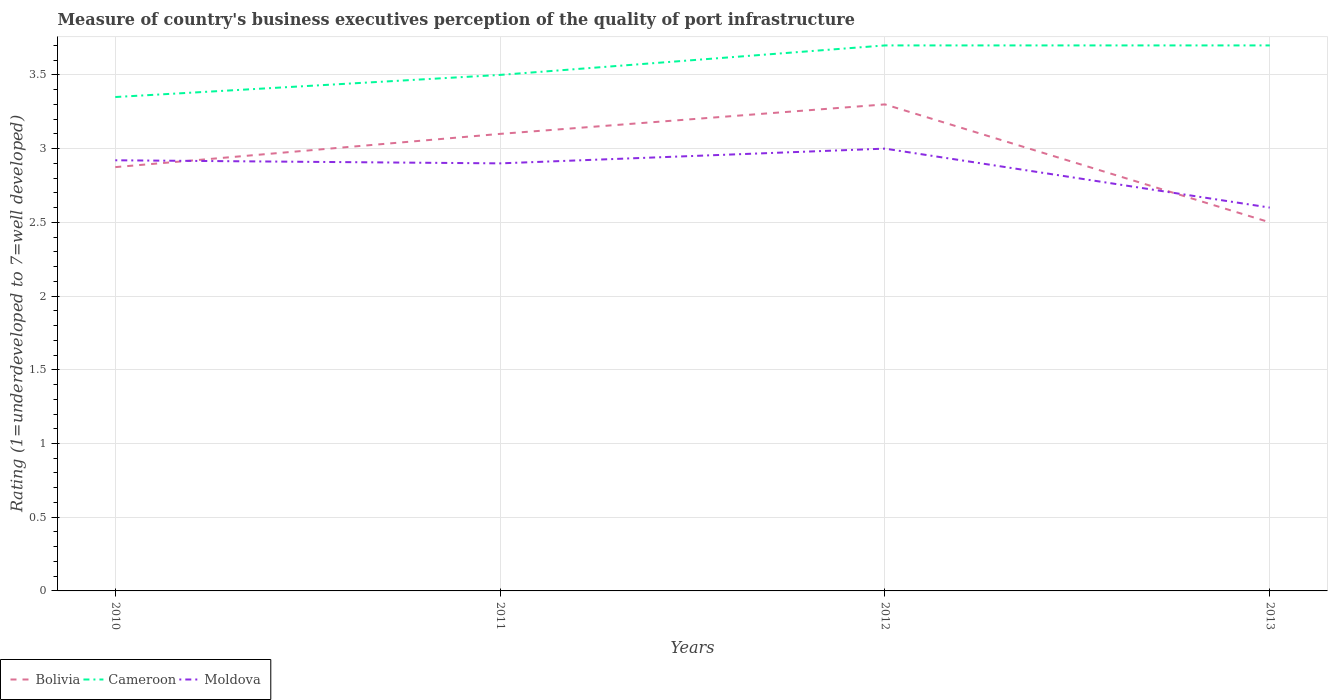What is the total ratings of the quality of port infrastructure in Cameroon in the graph?
Make the answer very short. -0.2. What is the difference between the highest and the second highest ratings of the quality of port infrastructure in Bolivia?
Make the answer very short. 0.8. Is the ratings of the quality of port infrastructure in Cameroon strictly greater than the ratings of the quality of port infrastructure in Moldova over the years?
Your answer should be compact. No. How many lines are there?
Provide a succinct answer. 3. What is the difference between two consecutive major ticks on the Y-axis?
Offer a terse response. 0.5. Are the values on the major ticks of Y-axis written in scientific E-notation?
Your answer should be very brief. No. Does the graph contain any zero values?
Give a very brief answer. No. How many legend labels are there?
Your answer should be compact. 3. What is the title of the graph?
Offer a terse response. Measure of country's business executives perception of the quality of port infrastructure. What is the label or title of the X-axis?
Ensure brevity in your answer.  Years. What is the label or title of the Y-axis?
Make the answer very short. Rating (1=underdeveloped to 7=well developed). What is the Rating (1=underdeveloped to 7=well developed) in Bolivia in 2010?
Give a very brief answer. 2.87. What is the Rating (1=underdeveloped to 7=well developed) of Cameroon in 2010?
Offer a very short reply. 3.35. What is the Rating (1=underdeveloped to 7=well developed) of Moldova in 2010?
Your response must be concise. 2.92. What is the Rating (1=underdeveloped to 7=well developed) in Moldova in 2011?
Give a very brief answer. 2.9. What is the Rating (1=underdeveloped to 7=well developed) in Bolivia in 2012?
Your response must be concise. 3.3. What is the Rating (1=underdeveloped to 7=well developed) in Cameroon in 2012?
Make the answer very short. 3.7. What is the Rating (1=underdeveloped to 7=well developed) in Cameroon in 2013?
Keep it short and to the point. 3.7. Across all years, what is the maximum Rating (1=underdeveloped to 7=well developed) of Moldova?
Provide a short and direct response. 3. Across all years, what is the minimum Rating (1=underdeveloped to 7=well developed) in Bolivia?
Keep it short and to the point. 2.5. Across all years, what is the minimum Rating (1=underdeveloped to 7=well developed) of Cameroon?
Offer a terse response. 3.35. What is the total Rating (1=underdeveloped to 7=well developed) in Bolivia in the graph?
Offer a terse response. 11.77. What is the total Rating (1=underdeveloped to 7=well developed) in Cameroon in the graph?
Ensure brevity in your answer.  14.25. What is the total Rating (1=underdeveloped to 7=well developed) in Moldova in the graph?
Provide a short and direct response. 11.42. What is the difference between the Rating (1=underdeveloped to 7=well developed) in Bolivia in 2010 and that in 2011?
Provide a short and direct response. -0.23. What is the difference between the Rating (1=underdeveloped to 7=well developed) in Cameroon in 2010 and that in 2011?
Your response must be concise. -0.15. What is the difference between the Rating (1=underdeveloped to 7=well developed) in Moldova in 2010 and that in 2011?
Your answer should be very brief. 0.02. What is the difference between the Rating (1=underdeveloped to 7=well developed) of Bolivia in 2010 and that in 2012?
Make the answer very short. -0.43. What is the difference between the Rating (1=underdeveloped to 7=well developed) of Cameroon in 2010 and that in 2012?
Your response must be concise. -0.35. What is the difference between the Rating (1=underdeveloped to 7=well developed) of Moldova in 2010 and that in 2012?
Ensure brevity in your answer.  -0.08. What is the difference between the Rating (1=underdeveloped to 7=well developed) in Bolivia in 2010 and that in 2013?
Your response must be concise. 0.37. What is the difference between the Rating (1=underdeveloped to 7=well developed) in Cameroon in 2010 and that in 2013?
Offer a very short reply. -0.35. What is the difference between the Rating (1=underdeveloped to 7=well developed) of Moldova in 2010 and that in 2013?
Your answer should be very brief. 0.32. What is the difference between the Rating (1=underdeveloped to 7=well developed) in Bolivia in 2011 and that in 2012?
Offer a terse response. -0.2. What is the difference between the Rating (1=underdeveloped to 7=well developed) of Cameroon in 2011 and that in 2012?
Provide a succinct answer. -0.2. What is the difference between the Rating (1=underdeveloped to 7=well developed) of Moldova in 2011 and that in 2012?
Provide a succinct answer. -0.1. What is the difference between the Rating (1=underdeveloped to 7=well developed) of Bolivia in 2011 and that in 2013?
Provide a short and direct response. 0.6. What is the difference between the Rating (1=underdeveloped to 7=well developed) of Bolivia in 2012 and that in 2013?
Provide a short and direct response. 0.8. What is the difference between the Rating (1=underdeveloped to 7=well developed) of Cameroon in 2012 and that in 2013?
Make the answer very short. 0. What is the difference between the Rating (1=underdeveloped to 7=well developed) of Bolivia in 2010 and the Rating (1=underdeveloped to 7=well developed) of Cameroon in 2011?
Provide a short and direct response. -0.63. What is the difference between the Rating (1=underdeveloped to 7=well developed) of Bolivia in 2010 and the Rating (1=underdeveloped to 7=well developed) of Moldova in 2011?
Keep it short and to the point. -0.03. What is the difference between the Rating (1=underdeveloped to 7=well developed) of Cameroon in 2010 and the Rating (1=underdeveloped to 7=well developed) of Moldova in 2011?
Ensure brevity in your answer.  0.45. What is the difference between the Rating (1=underdeveloped to 7=well developed) of Bolivia in 2010 and the Rating (1=underdeveloped to 7=well developed) of Cameroon in 2012?
Give a very brief answer. -0.83. What is the difference between the Rating (1=underdeveloped to 7=well developed) in Bolivia in 2010 and the Rating (1=underdeveloped to 7=well developed) in Moldova in 2012?
Give a very brief answer. -0.13. What is the difference between the Rating (1=underdeveloped to 7=well developed) in Cameroon in 2010 and the Rating (1=underdeveloped to 7=well developed) in Moldova in 2012?
Provide a short and direct response. 0.35. What is the difference between the Rating (1=underdeveloped to 7=well developed) of Bolivia in 2010 and the Rating (1=underdeveloped to 7=well developed) of Cameroon in 2013?
Ensure brevity in your answer.  -0.83. What is the difference between the Rating (1=underdeveloped to 7=well developed) in Bolivia in 2010 and the Rating (1=underdeveloped to 7=well developed) in Moldova in 2013?
Keep it short and to the point. 0.27. What is the difference between the Rating (1=underdeveloped to 7=well developed) of Cameroon in 2010 and the Rating (1=underdeveloped to 7=well developed) of Moldova in 2013?
Provide a short and direct response. 0.75. What is the difference between the Rating (1=underdeveloped to 7=well developed) in Bolivia in 2011 and the Rating (1=underdeveloped to 7=well developed) in Moldova in 2012?
Your answer should be very brief. 0.1. What is the difference between the Rating (1=underdeveloped to 7=well developed) in Bolivia in 2011 and the Rating (1=underdeveloped to 7=well developed) in Cameroon in 2013?
Keep it short and to the point. -0.6. What is the difference between the Rating (1=underdeveloped to 7=well developed) of Bolivia in 2012 and the Rating (1=underdeveloped to 7=well developed) of Moldova in 2013?
Offer a terse response. 0.7. What is the difference between the Rating (1=underdeveloped to 7=well developed) in Cameroon in 2012 and the Rating (1=underdeveloped to 7=well developed) in Moldova in 2013?
Make the answer very short. 1.1. What is the average Rating (1=underdeveloped to 7=well developed) of Bolivia per year?
Ensure brevity in your answer.  2.94. What is the average Rating (1=underdeveloped to 7=well developed) of Cameroon per year?
Give a very brief answer. 3.56. What is the average Rating (1=underdeveloped to 7=well developed) of Moldova per year?
Keep it short and to the point. 2.86. In the year 2010, what is the difference between the Rating (1=underdeveloped to 7=well developed) of Bolivia and Rating (1=underdeveloped to 7=well developed) of Cameroon?
Provide a succinct answer. -0.48. In the year 2010, what is the difference between the Rating (1=underdeveloped to 7=well developed) in Bolivia and Rating (1=underdeveloped to 7=well developed) in Moldova?
Your answer should be very brief. -0.05. In the year 2010, what is the difference between the Rating (1=underdeveloped to 7=well developed) of Cameroon and Rating (1=underdeveloped to 7=well developed) of Moldova?
Your response must be concise. 0.43. In the year 2011, what is the difference between the Rating (1=underdeveloped to 7=well developed) of Bolivia and Rating (1=underdeveloped to 7=well developed) of Moldova?
Ensure brevity in your answer.  0.2. In the year 2011, what is the difference between the Rating (1=underdeveloped to 7=well developed) of Cameroon and Rating (1=underdeveloped to 7=well developed) of Moldova?
Ensure brevity in your answer.  0.6. In the year 2012, what is the difference between the Rating (1=underdeveloped to 7=well developed) of Bolivia and Rating (1=underdeveloped to 7=well developed) of Cameroon?
Offer a very short reply. -0.4. In the year 2013, what is the difference between the Rating (1=underdeveloped to 7=well developed) in Bolivia and Rating (1=underdeveloped to 7=well developed) in Cameroon?
Make the answer very short. -1.2. What is the ratio of the Rating (1=underdeveloped to 7=well developed) in Bolivia in 2010 to that in 2011?
Make the answer very short. 0.93. What is the ratio of the Rating (1=underdeveloped to 7=well developed) of Cameroon in 2010 to that in 2011?
Keep it short and to the point. 0.96. What is the ratio of the Rating (1=underdeveloped to 7=well developed) in Bolivia in 2010 to that in 2012?
Your answer should be very brief. 0.87. What is the ratio of the Rating (1=underdeveloped to 7=well developed) in Cameroon in 2010 to that in 2012?
Offer a very short reply. 0.91. What is the ratio of the Rating (1=underdeveloped to 7=well developed) of Moldova in 2010 to that in 2012?
Keep it short and to the point. 0.97. What is the ratio of the Rating (1=underdeveloped to 7=well developed) in Bolivia in 2010 to that in 2013?
Your response must be concise. 1.15. What is the ratio of the Rating (1=underdeveloped to 7=well developed) of Cameroon in 2010 to that in 2013?
Your answer should be compact. 0.91. What is the ratio of the Rating (1=underdeveloped to 7=well developed) of Moldova in 2010 to that in 2013?
Give a very brief answer. 1.12. What is the ratio of the Rating (1=underdeveloped to 7=well developed) in Bolivia in 2011 to that in 2012?
Keep it short and to the point. 0.94. What is the ratio of the Rating (1=underdeveloped to 7=well developed) of Cameroon in 2011 to that in 2012?
Your answer should be compact. 0.95. What is the ratio of the Rating (1=underdeveloped to 7=well developed) in Moldova in 2011 to that in 2012?
Provide a short and direct response. 0.97. What is the ratio of the Rating (1=underdeveloped to 7=well developed) in Bolivia in 2011 to that in 2013?
Offer a very short reply. 1.24. What is the ratio of the Rating (1=underdeveloped to 7=well developed) of Cameroon in 2011 to that in 2013?
Your answer should be compact. 0.95. What is the ratio of the Rating (1=underdeveloped to 7=well developed) in Moldova in 2011 to that in 2013?
Keep it short and to the point. 1.12. What is the ratio of the Rating (1=underdeveloped to 7=well developed) in Bolivia in 2012 to that in 2013?
Offer a very short reply. 1.32. What is the ratio of the Rating (1=underdeveloped to 7=well developed) of Cameroon in 2012 to that in 2013?
Provide a succinct answer. 1. What is the ratio of the Rating (1=underdeveloped to 7=well developed) in Moldova in 2012 to that in 2013?
Ensure brevity in your answer.  1.15. What is the difference between the highest and the second highest Rating (1=underdeveloped to 7=well developed) of Moldova?
Your answer should be very brief. 0.08. What is the difference between the highest and the lowest Rating (1=underdeveloped to 7=well developed) of Bolivia?
Make the answer very short. 0.8. 